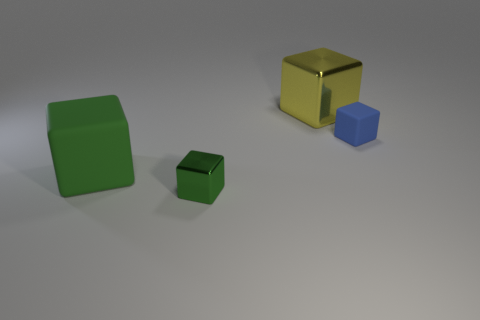Subtract 1 cubes. How many cubes are left? 3 Add 2 gray rubber cylinders. How many objects exist? 6 Add 3 big gray cubes. How many big gray cubes exist? 3 Subtract 0 cyan balls. How many objects are left? 4 Subtract all big matte things. Subtract all gray metallic cylinders. How many objects are left? 3 Add 2 big yellow metallic blocks. How many big yellow metallic blocks are left? 3 